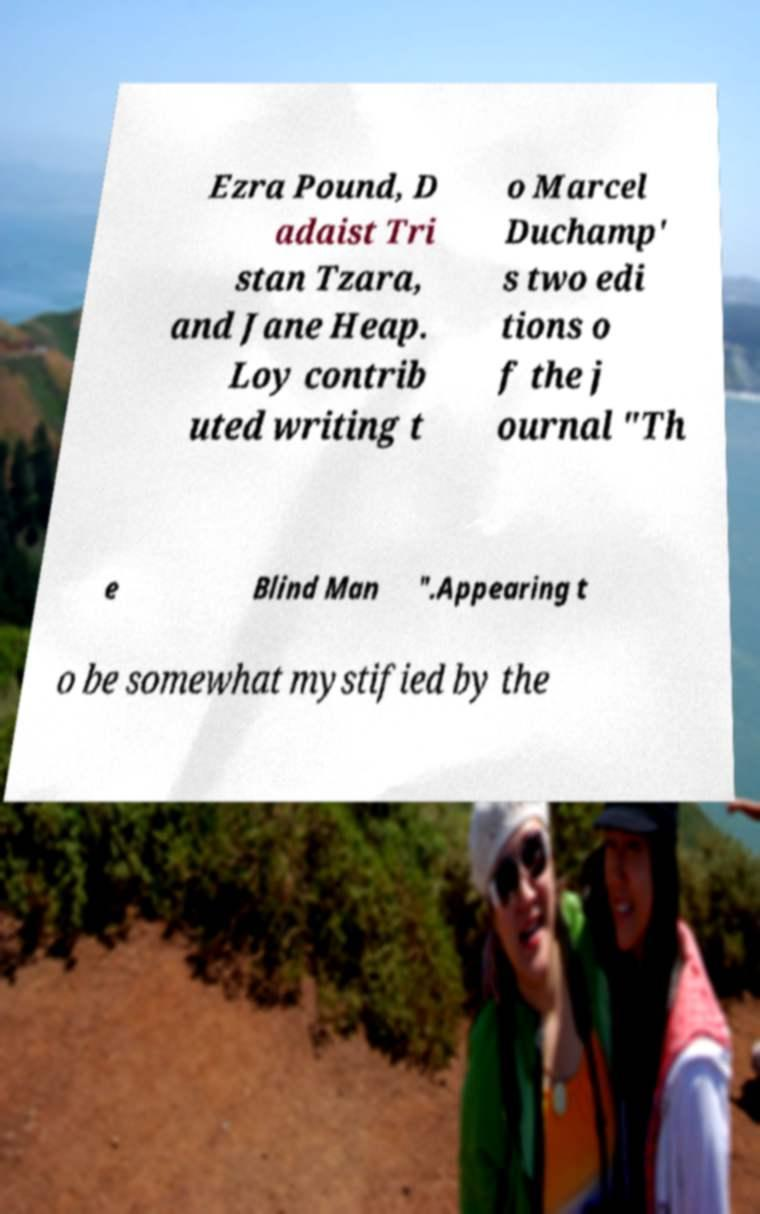Please identify and transcribe the text found in this image. Ezra Pound, D adaist Tri stan Tzara, and Jane Heap. Loy contrib uted writing t o Marcel Duchamp' s two edi tions o f the j ournal "Th e Blind Man ".Appearing t o be somewhat mystified by the 